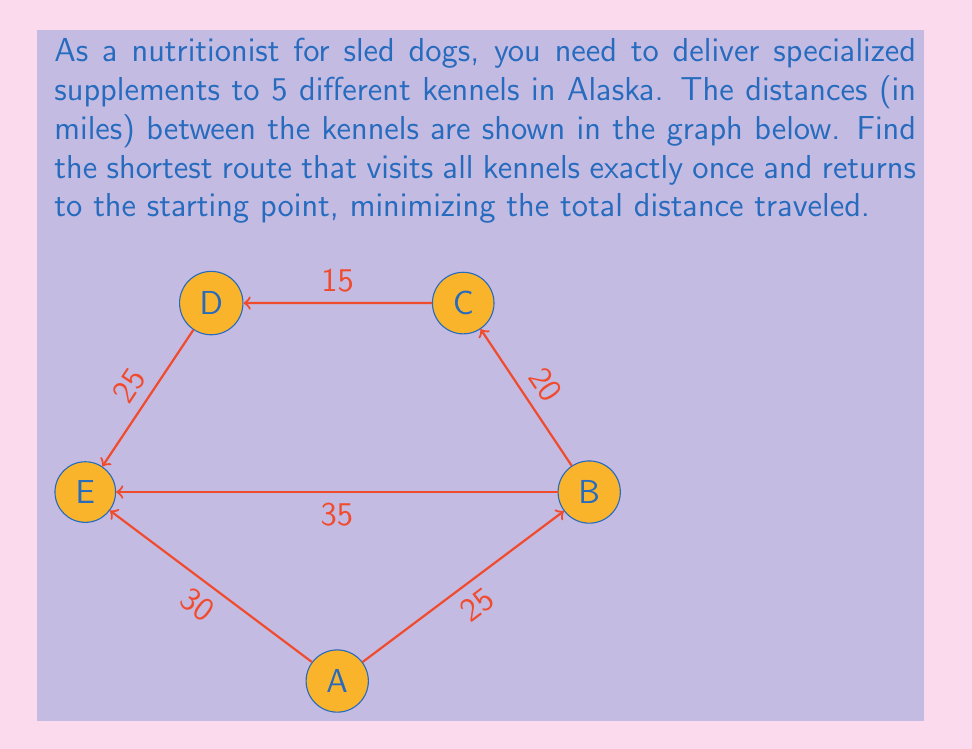Teach me how to tackle this problem. To solve this problem, we'll use the Held-Karp algorithm, which is an exact method for solving the Traveling Salesman Problem (TSP).

Step 1: Initialize the distance matrix D
$$D = \begin{bmatrix}
0 & 25 & \infty & \infty & 30 \\
25 & 0 & 20 & \infty & 35 \\
\infty & 20 & 0 & 15 & \infty \\
\infty & \infty & 15 & 0 & 25 \\
30 & 35 & \infty & 25 & 0
\end{bmatrix}$$

Step 2: Initialize the dynamic programming table
Let $C(S, i)$ be the cost of the shortest path visiting each vertex in set $S$ exactly once, starting at vertex 1 (A) and ending at vertex $i$.

Step 3: Compute base cases
For all $i \neq 1$: $C(\{i\}, i) = D_{1i}$

Step 4: Compute for subsets of increasing size
For $s = 2$ to $n-1$:
  For all subsets $S$ of size $s$, not containing 1:
    For all $i \in S$:
      $C(S, i) = \min_{j \in S, j \neq i} [C(S - \{i\}, j) + D_{ji}]$

Step 5: Compute the final result
$\text{TSP} = \min_{i \neq 1} [C(\{2, 3, 4, 5\}, i) + D_{i1}]$

After performing these computations, we find:

The optimal tour is A → B → C → D → E → A
The total distance is 25 + 20 + 15 + 25 + 30 = 115 miles
Answer: 115 miles 